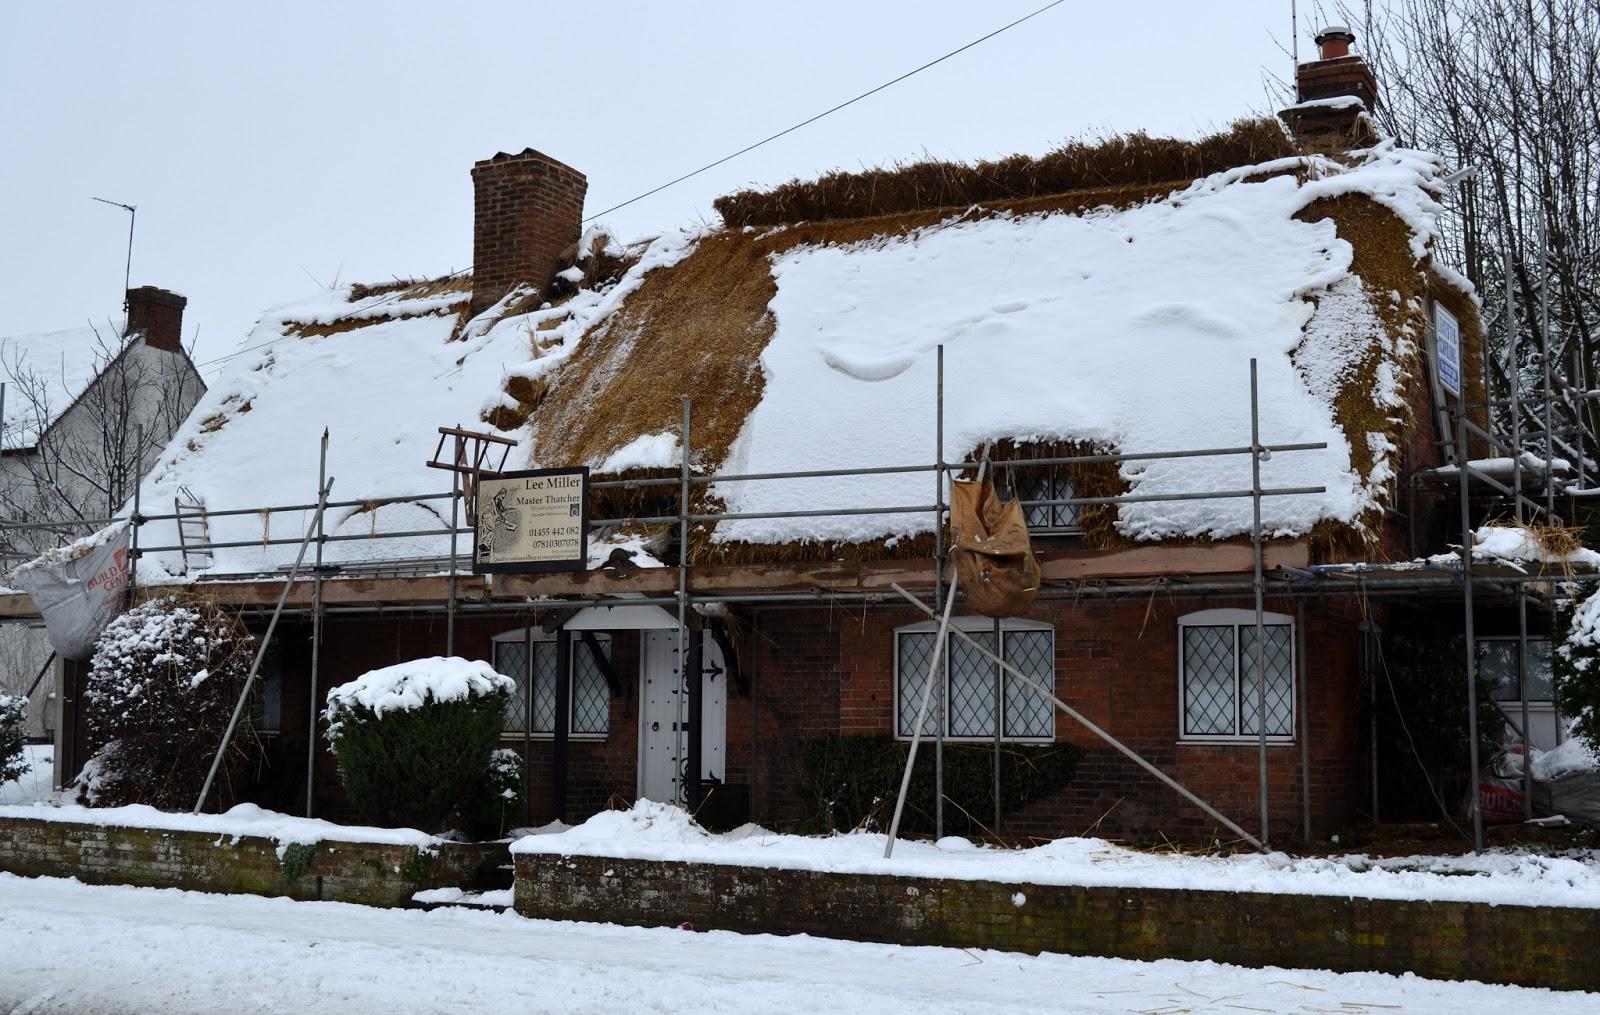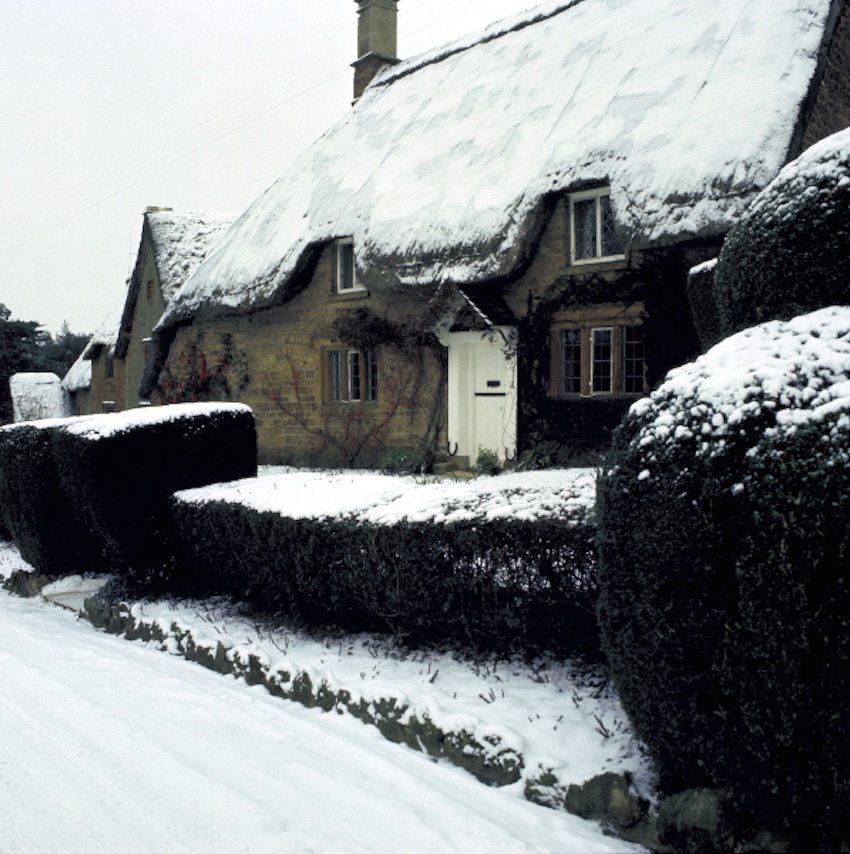The first image is the image on the left, the second image is the image on the right. Analyze the images presented: Is the assertion "There is blue sky in at least one image." valid? Answer yes or no. No. 